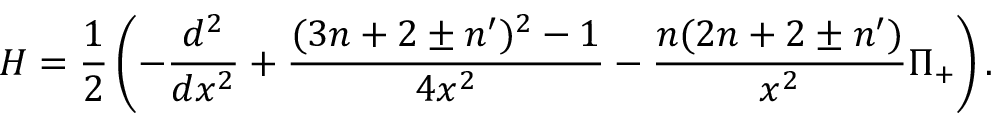<formula> <loc_0><loc_0><loc_500><loc_500>H = \frac { 1 } { 2 } \left ( - \frac { d ^ { 2 } } { d x ^ { 2 } } + \frac { ( 3 n + 2 \pm n ^ { \prime } ) ^ { 2 } - 1 } { 4 x ^ { 2 } } - \frac { n ( 2 n + 2 \pm n ^ { \prime } ) } { x ^ { 2 } } \Pi _ { + } \right ) .</formula> 